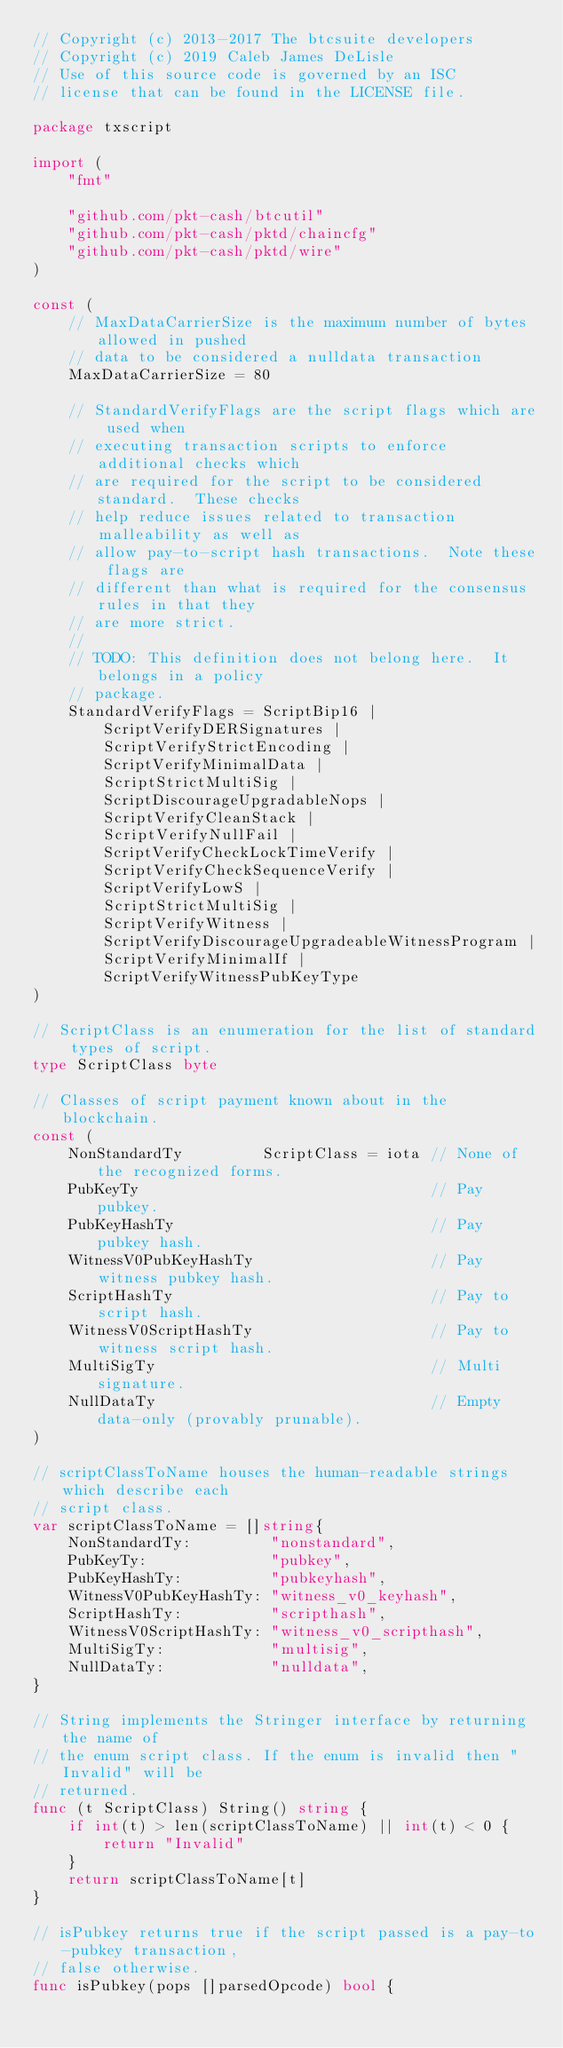<code> <loc_0><loc_0><loc_500><loc_500><_Go_>// Copyright (c) 2013-2017 The btcsuite developers
// Copyright (c) 2019 Caleb James DeLisle
// Use of this source code is governed by an ISC
// license that can be found in the LICENSE file.

package txscript

import (
	"fmt"

	"github.com/pkt-cash/btcutil"
	"github.com/pkt-cash/pktd/chaincfg"
	"github.com/pkt-cash/pktd/wire"
)

const (
	// MaxDataCarrierSize is the maximum number of bytes allowed in pushed
	// data to be considered a nulldata transaction
	MaxDataCarrierSize = 80

	// StandardVerifyFlags are the script flags which are used when
	// executing transaction scripts to enforce additional checks which
	// are required for the script to be considered standard.  These checks
	// help reduce issues related to transaction malleability as well as
	// allow pay-to-script hash transactions.  Note these flags are
	// different than what is required for the consensus rules in that they
	// are more strict.
	//
	// TODO: This definition does not belong here.  It belongs in a policy
	// package.
	StandardVerifyFlags = ScriptBip16 |
		ScriptVerifyDERSignatures |
		ScriptVerifyStrictEncoding |
		ScriptVerifyMinimalData |
		ScriptStrictMultiSig |
		ScriptDiscourageUpgradableNops |
		ScriptVerifyCleanStack |
		ScriptVerifyNullFail |
		ScriptVerifyCheckLockTimeVerify |
		ScriptVerifyCheckSequenceVerify |
		ScriptVerifyLowS |
		ScriptStrictMultiSig |
		ScriptVerifyWitness |
		ScriptVerifyDiscourageUpgradeableWitnessProgram |
		ScriptVerifyMinimalIf |
		ScriptVerifyWitnessPubKeyType
)

// ScriptClass is an enumeration for the list of standard types of script.
type ScriptClass byte

// Classes of script payment known about in the blockchain.
const (
	NonStandardTy         ScriptClass = iota // None of the recognized forms.
	PubKeyTy                                 // Pay pubkey.
	PubKeyHashTy                             // Pay pubkey hash.
	WitnessV0PubKeyHashTy                    // Pay witness pubkey hash.
	ScriptHashTy                             // Pay to script hash.
	WitnessV0ScriptHashTy                    // Pay to witness script hash.
	MultiSigTy                               // Multi signature.
	NullDataTy                               // Empty data-only (provably prunable).
)

// scriptClassToName houses the human-readable strings which describe each
// script class.
var scriptClassToName = []string{
	NonStandardTy:         "nonstandard",
	PubKeyTy:              "pubkey",
	PubKeyHashTy:          "pubkeyhash",
	WitnessV0PubKeyHashTy: "witness_v0_keyhash",
	ScriptHashTy:          "scripthash",
	WitnessV0ScriptHashTy: "witness_v0_scripthash",
	MultiSigTy:            "multisig",
	NullDataTy:            "nulldata",
}

// String implements the Stringer interface by returning the name of
// the enum script class. If the enum is invalid then "Invalid" will be
// returned.
func (t ScriptClass) String() string {
	if int(t) > len(scriptClassToName) || int(t) < 0 {
		return "Invalid"
	}
	return scriptClassToName[t]
}

// isPubkey returns true if the script passed is a pay-to-pubkey transaction,
// false otherwise.
func isPubkey(pops []parsedOpcode) bool {</code> 